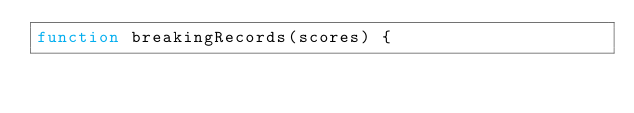<code> <loc_0><loc_0><loc_500><loc_500><_JavaScript_>function breakingRecords(scores) {</code> 